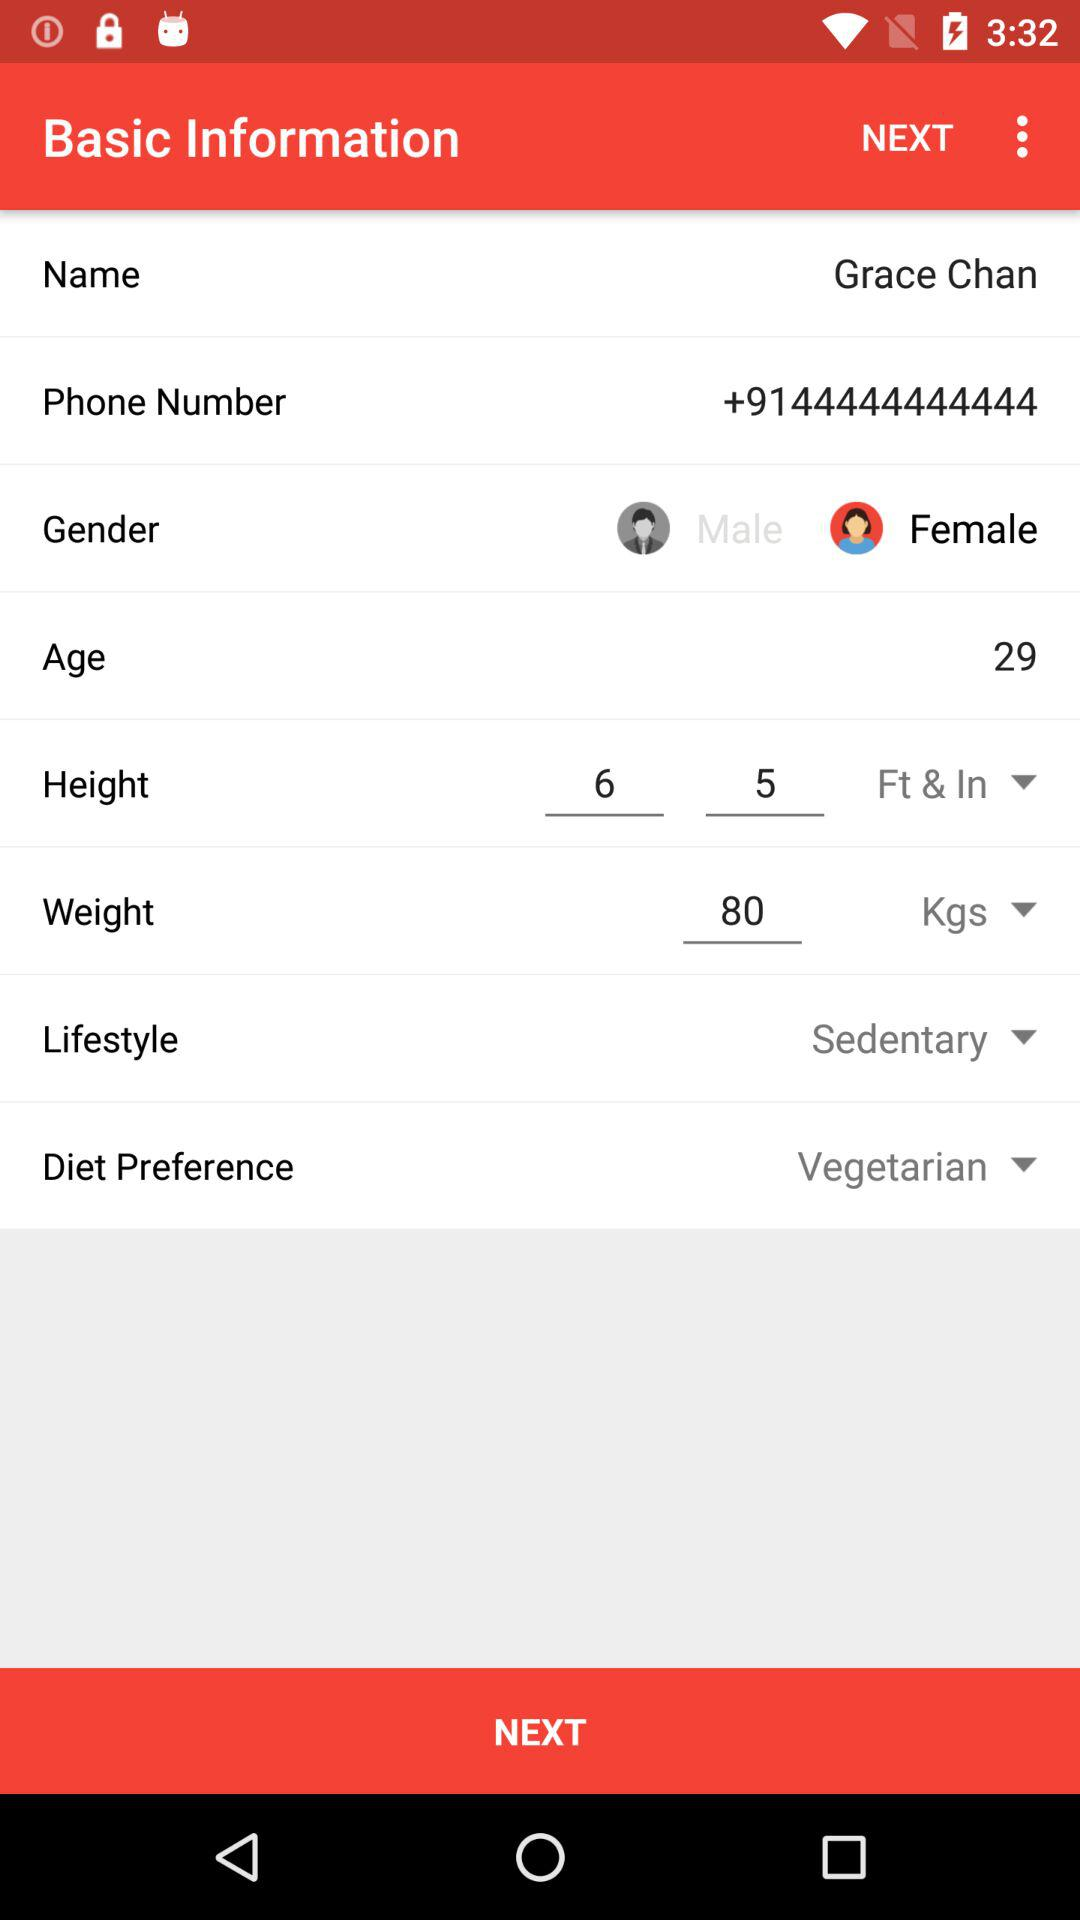What is the name of the user? The name of the user is Grace Chan. 